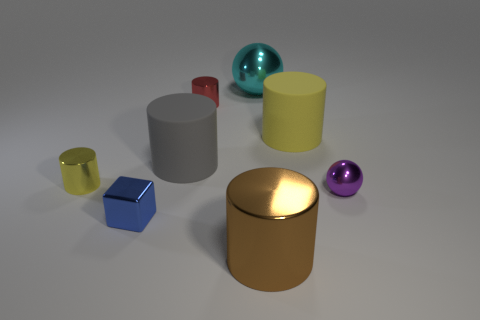Can you describe the atmosphere or mood conveyed by the image? The image has a calm and sterile atmosphere, with objects placed on what appears to be a matte surface and illuminated by soft, diffused lighting. The composition is orderly and the background is neutral, promoting focus on the shapes and colors of the objects. 